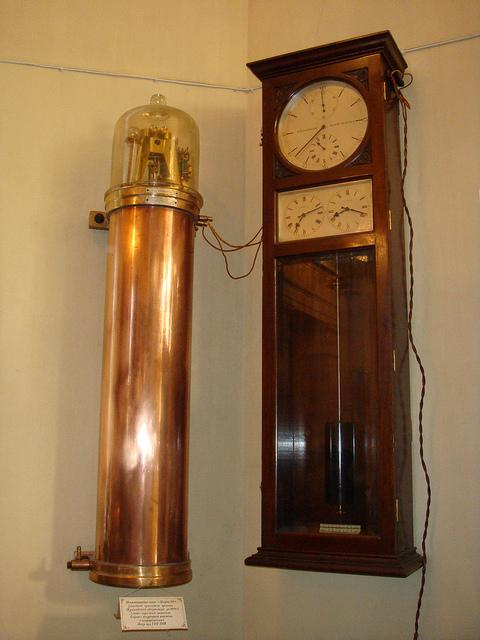What is connected to the long cylinder? Please explain your reasoning. clock. There is a round part with arms. 